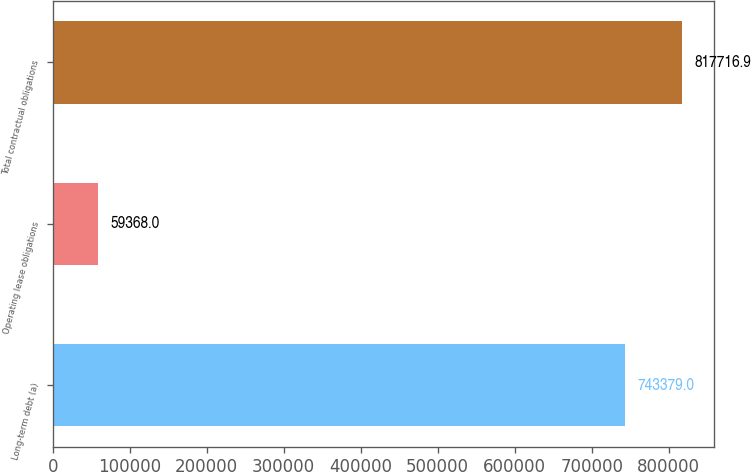Convert chart to OTSL. <chart><loc_0><loc_0><loc_500><loc_500><bar_chart><fcel>Long-term debt (a)<fcel>Operating lease obligations<fcel>Total contractual obligations<nl><fcel>743379<fcel>59368<fcel>817717<nl></chart> 